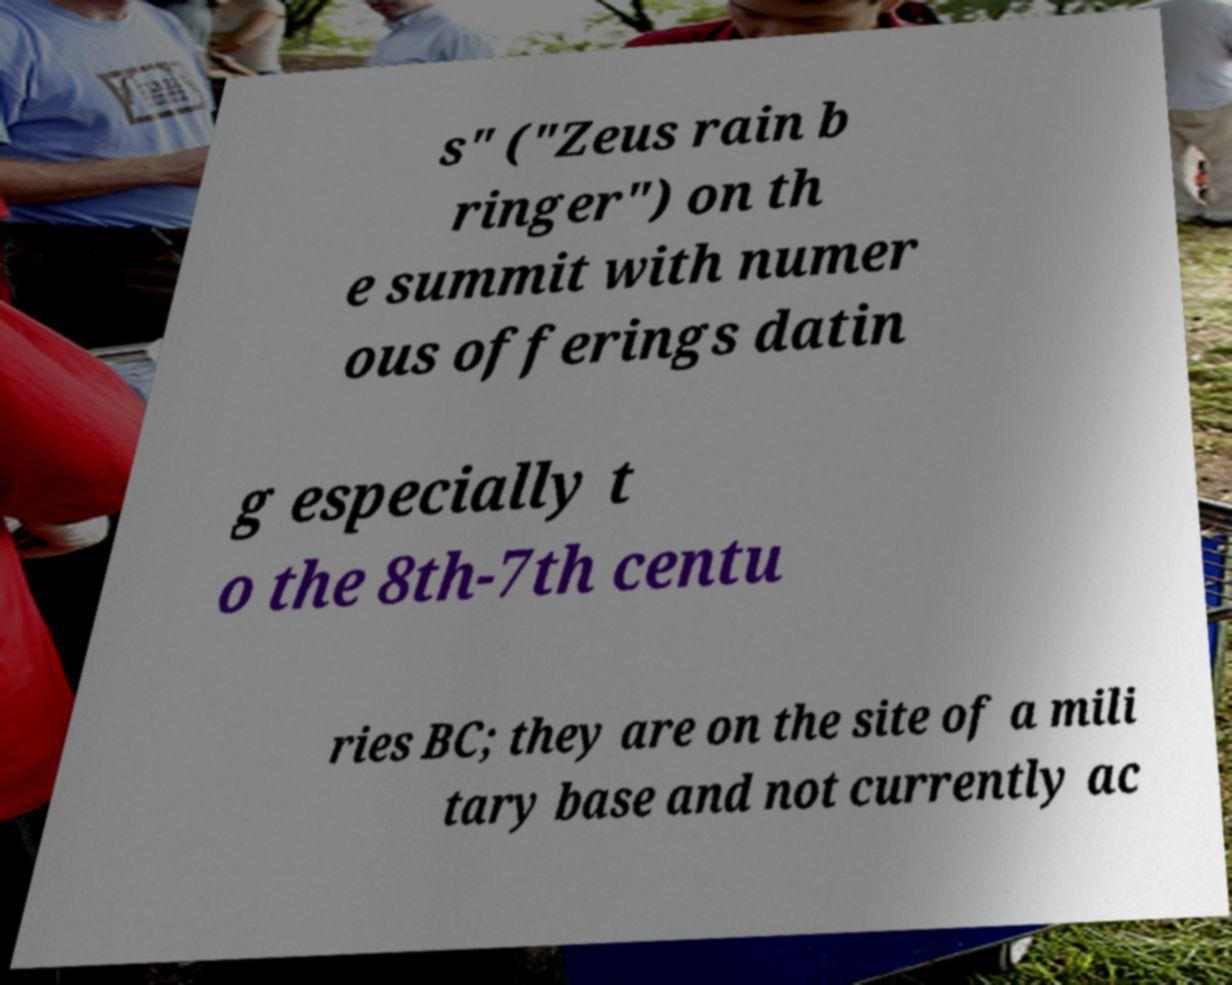For documentation purposes, I need the text within this image transcribed. Could you provide that? s" ("Zeus rain b ringer") on th e summit with numer ous offerings datin g especially t o the 8th-7th centu ries BC; they are on the site of a mili tary base and not currently ac 